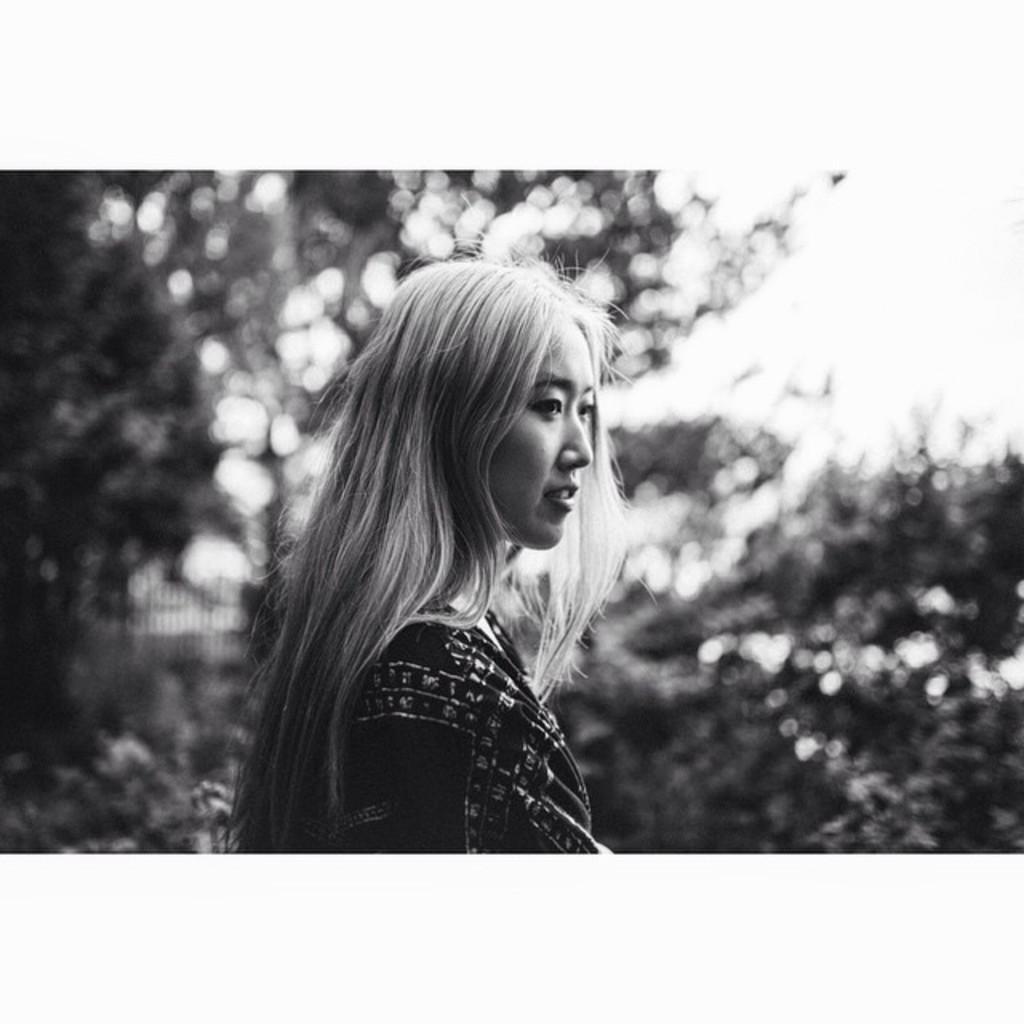Can you describe this image briefly? A beautiful woman is there, she wore dress. It is in black and white. 